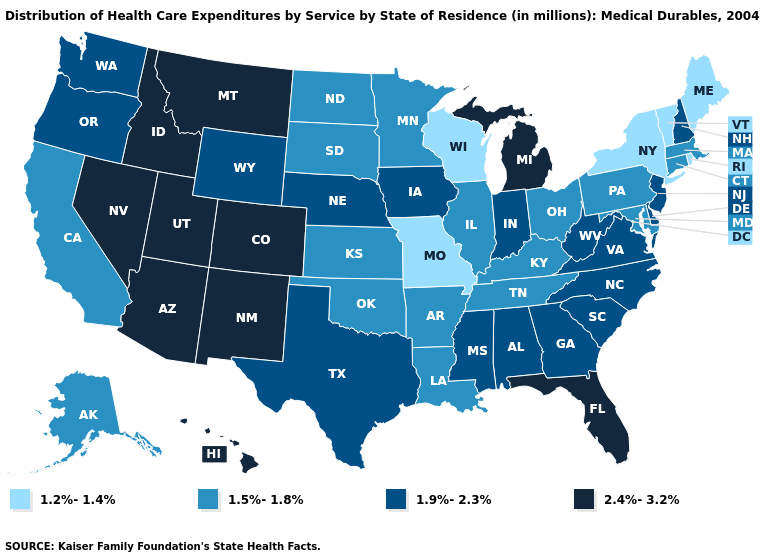What is the lowest value in the West?
Concise answer only. 1.5%-1.8%. Among the states that border Kentucky , does Indiana have the highest value?
Keep it brief. Yes. Name the states that have a value in the range 2.4%-3.2%?
Keep it brief. Arizona, Colorado, Florida, Hawaii, Idaho, Michigan, Montana, Nevada, New Mexico, Utah. What is the lowest value in the USA?
Quick response, please. 1.2%-1.4%. Among the states that border Oregon , does California have the lowest value?
Write a very short answer. Yes. Which states have the lowest value in the USA?
Be succinct. Maine, Missouri, New York, Rhode Island, Vermont, Wisconsin. Does Vermont have the lowest value in the USA?
Be succinct. Yes. What is the value of Arizona?
Answer briefly. 2.4%-3.2%. Does Minnesota have a lower value than Vermont?
Quick response, please. No. Which states have the lowest value in the West?
Quick response, please. Alaska, California. What is the value of New Mexico?
Concise answer only. 2.4%-3.2%. What is the highest value in states that border Washington?
Short answer required. 2.4%-3.2%. Name the states that have a value in the range 2.4%-3.2%?
Quick response, please. Arizona, Colorado, Florida, Hawaii, Idaho, Michigan, Montana, Nevada, New Mexico, Utah. What is the lowest value in the MidWest?
Quick response, please. 1.2%-1.4%. Does the map have missing data?
Be succinct. No. 